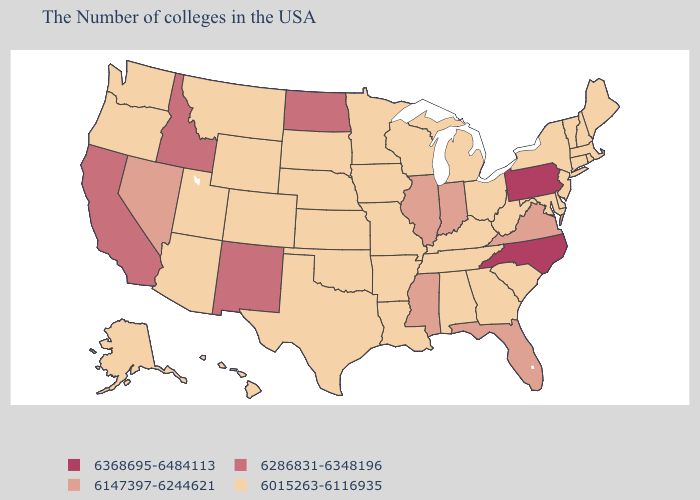What is the value of Kansas?
Answer briefly. 6015263-6116935. What is the highest value in states that border Washington?
Keep it brief. 6286831-6348196. Name the states that have a value in the range 6015263-6116935?
Short answer required. Maine, Massachusetts, Rhode Island, New Hampshire, Vermont, Connecticut, New York, New Jersey, Delaware, Maryland, South Carolina, West Virginia, Ohio, Georgia, Michigan, Kentucky, Alabama, Tennessee, Wisconsin, Louisiana, Missouri, Arkansas, Minnesota, Iowa, Kansas, Nebraska, Oklahoma, Texas, South Dakota, Wyoming, Colorado, Utah, Montana, Arizona, Washington, Oregon, Alaska, Hawaii. Name the states that have a value in the range 6147397-6244621?
Give a very brief answer. Virginia, Florida, Indiana, Illinois, Mississippi, Nevada. What is the value of Connecticut?
Be succinct. 6015263-6116935. Name the states that have a value in the range 6368695-6484113?
Quick response, please. Pennsylvania, North Carolina. What is the lowest value in the Northeast?
Give a very brief answer. 6015263-6116935. What is the value of Iowa?
Give a very brief answer. 6015263-6116935. Among the states that border Nevada , does California have the lowest value?
Short answer required. No. Is the legend a continuous bar?
Quick response, please. No. Does Ohio have the highest value in the MidWest?
Give a very brief answer. No. What is the highest value in the USA?
Be succinct. 6368695-6484113. Does Missouri have a lower value than Kentucky?
Quick response, please. No. What is the highest value in states that border Louisiana?
Be succinct. 6147397-6244621. Name the states that have a value in the range 6147397-6244621?
Write a very short answer. Virginia, Florida, Indiana, Illinois, Mississippi, Nevada. 